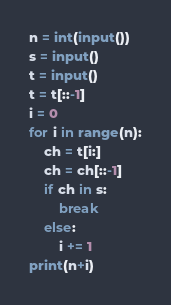Convert code to text. <code><loc_0><loc_0><loc_500><loc_500><_Python_>n = int(input())
s = input()
t = input()
t = t[::-1]
i = 0
for i in range(n):
    ch = t[i:]
    ch = ch[::-1]
    if ch in s:
        break
    else:
        i += 1
print(n+i)</code> 